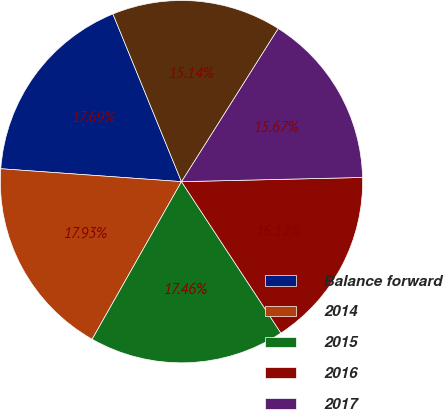Convert chart to OTSL. <chart><loc_0><loc_0><loc_500><loc_500><pie_chart><fcel>Balance forward<fcel>2014<fcel>2015<fcel>2016<fcel>2017<fcel>2018<nl><fcel>17.69%<fcel>17.93%<fcel>17.46%<fcel>16.12%<fcel>15.67%<fcel>15.14%<nl></chart> 